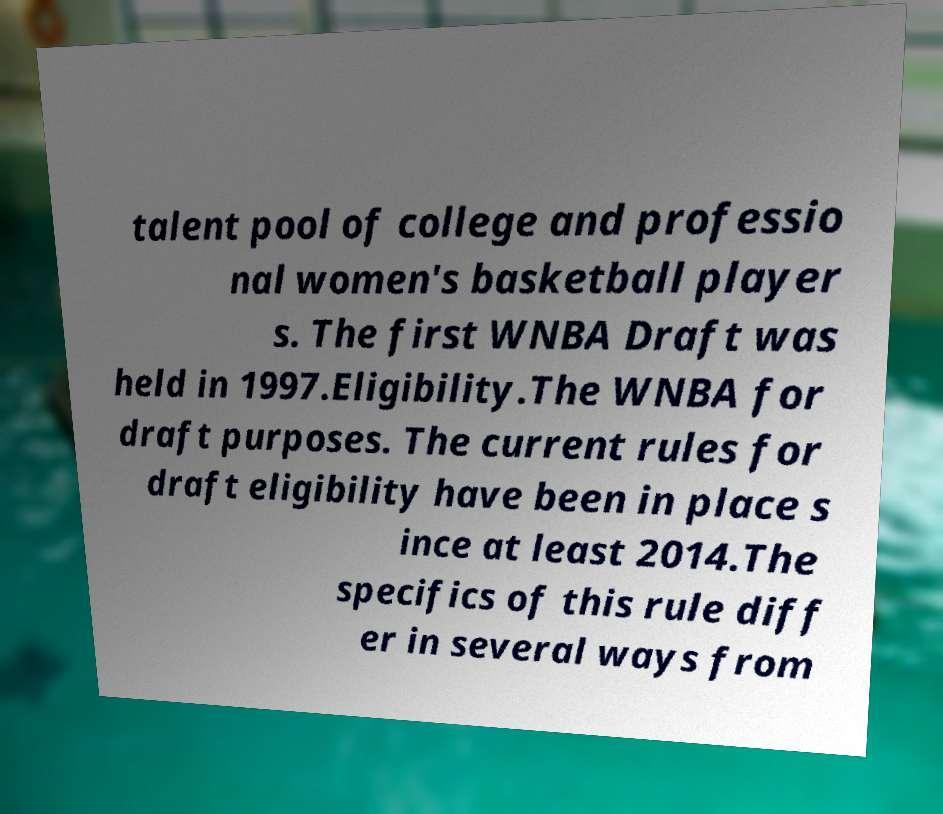Can you read and provide the text displayed in the image?This photo seems to have some interesting text. Can you extract and type it out for me? talent pool of college and professio nal women's basketball player s. The first WNBA Draft was held in 1997.Eligibility.The WNBA for draft purposes. The current rules for draft eligibility have been in place s ince at least 2014.The specifics of this rule diff er in several ways from 